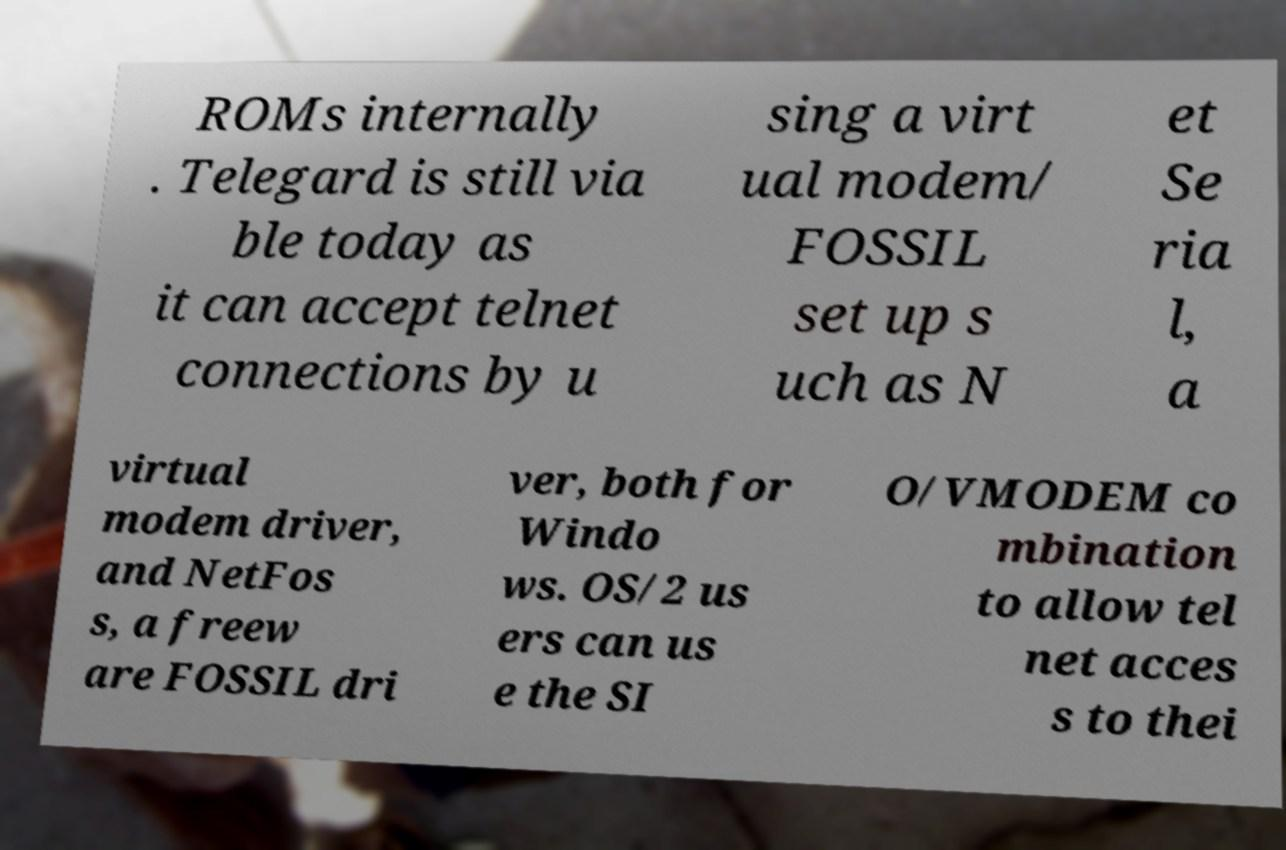There's text embedded in this image that I need extracted. Can you transcribe it verbatim? ROMs internally . Telegard is still via ble today as it can accept telnet connections by u sing a virt ual modem/ FOSSIL set up s uch as N et Se ria l, a virtual modem driver, and NetFos s, a freew are FOSSIL dri ver, both for Windo ws. OS/2 us ers can us e the SI O/VMODEM co mbination to allow tel net acces s to thei 